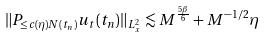<formula> <loc_0><loc_0><loc_500><loc_500>\| P _ { \leq c ( \eta ) N ( t _ { n } ) } u _ { t } ( t _ { n } ) \| _ { L _ { x } ^ { 2 } } & \lesssim M ^ { \frac { 5 \beta } { 6 } } + M ^ { - 1 / 2 } \eta</formula> 